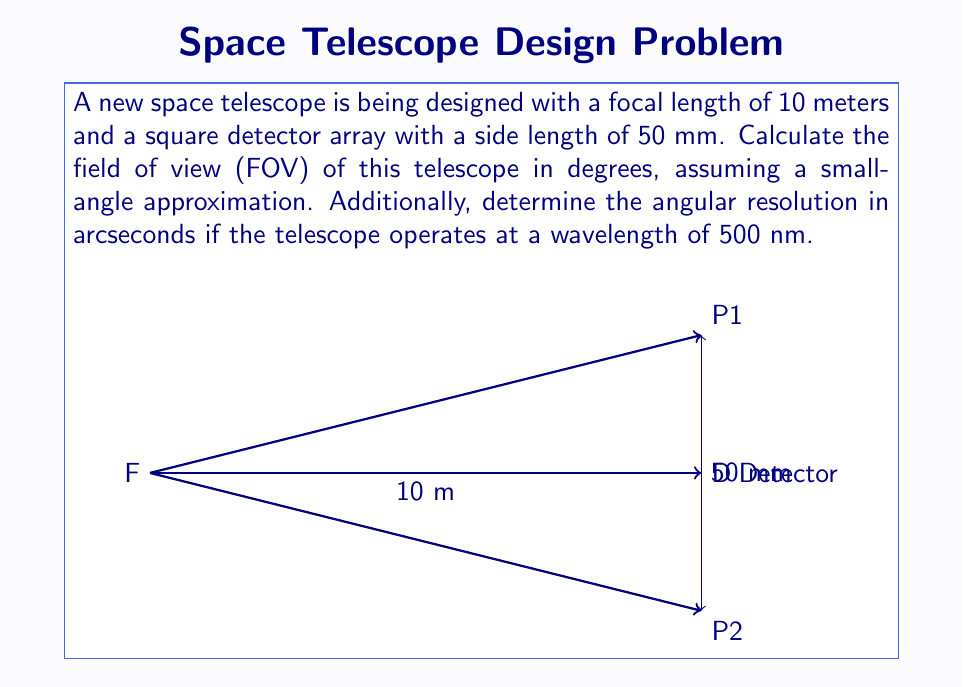Show me your answer to this math problem. Let's approach this problem step-by-step:

1) Field of View (FOV) calculation:
   The FOV is determined by the angle subtended by the detector at the focal point.
   
   For small angles, we can use the approximation: $\tan \theta \approx \theta$ (in radians)
   
   $\tan \theta = \frac{\text{detector size}}{2 \times \text{focal length}}$

   $\theta = \frac{50 \text{ mm}}{2 \times 10,000 \text{ mm}} = 0.0025 \text{ radians}$

2) Convert radians to degrees:
   $\theta_{degrees} = \theta_{radians} \times \frac{180^{\circ}}{\pi}$
   
   $\theta_{degrees} = 0.0025 \times \frac{180^{\circ}}{\pi} \approx 0.1432^{\circ}$

3) This is the half-angle FOV. For the full FOV, we double this value:
   $\text{FOV} = 2 \times 0.1432^{\circ} \approx 0.2864^{\circ}$

4) For the angular resolution, we use the Rayleigh criterion:
   $\theta_{min} = 1.22 \frac{\lambda}{D}$
   
   Where $\lambda$ is the wavelength and $D$ is the diameter of the telescope's primary mirror.
   
   We aren't given $D$, but we can calculate it using the focal ratio (f-number) formula:
   $f = \frac{f}{D}$, where $f$ is the focal length.
   
   Assuming a typical f-number of 10 for a space telescope:
   $D = \frac{f}{10} = \frac{10 \text{ m}}{10} = 1 \text{ m}$

5) Now we can calculate the angular resolution:
   $\theta_{min} = 1.22 \frac{500 \times 10^{-9} \text{ m}}{1 \text{ m}} = 6.1 \times 10^{-7} \text{ radians}$

6) Convert to arcseconds:
   $\theta_{arcsec} = \theta_{radians} \times \frac{180^{\circ}}{\pi} \times 3600$
   
   $\theta_{arcsec} = 6.1 \times 10^{-7} \times \frac{180^{\circ}}{\pi} \times 3600 \approx 0.126 \text{ arcseconds}$
Answer: FOV: $0.2864^{\circ}$, Angular resolution: $0.126$ arcseconds 